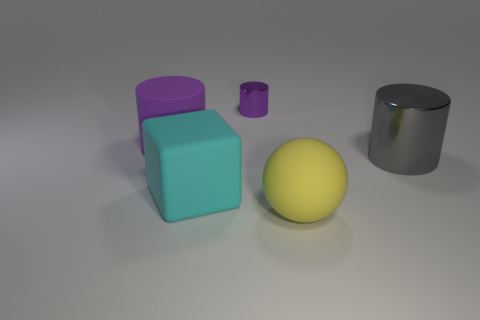Add 4 small purple objects. How many objects exist? 9 Subtract all blocks. How many objects are left? 4 Add 4 gray metallic cylinders. How many gray metallic cylinders are left? 5 Add 5 large things. How many large things exist? 9 Subtract 0 green balls. How many objects are left? 5 Subtract all big cyan objects. Subtract all yellow spheres. How many objects are left? 3 